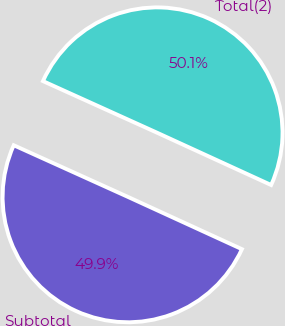<chart> <loc_0><loc_0><loc_500><loc_500><pie_chart><fcel>Subtotal<fcel>Total(2)<nl><fcel>49.92%<fcel>50.08%<nl></chart> 